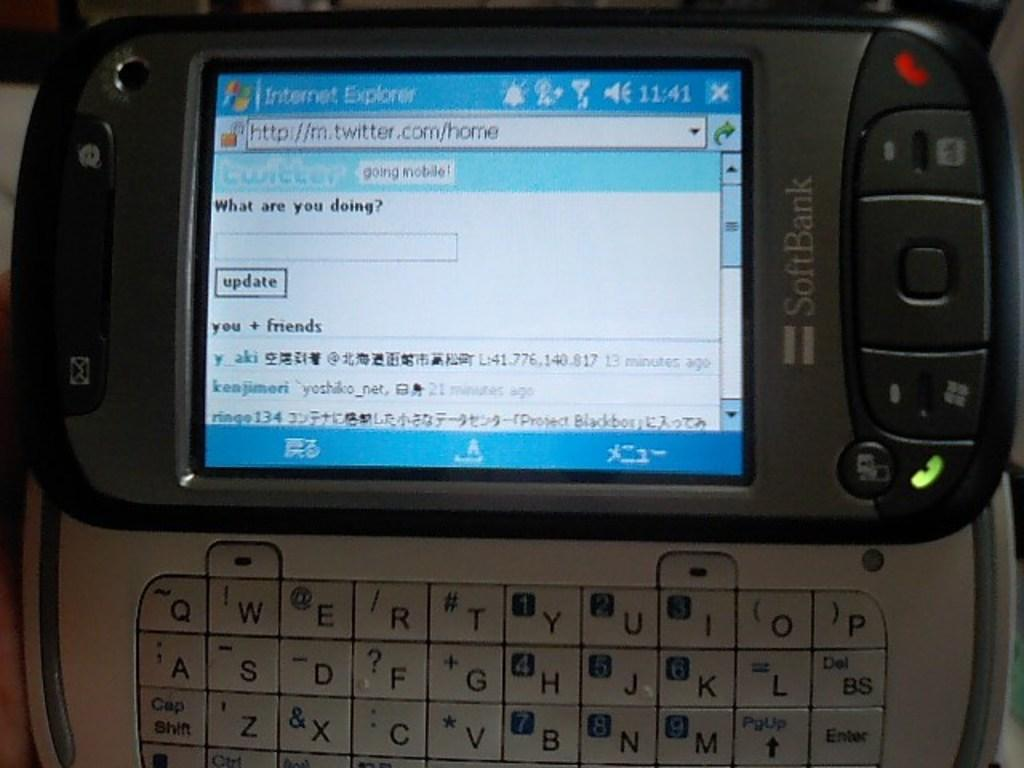<image>
Give a short and clear explanation of the subsequent image. A phone screen is open to Internet Explorer. 